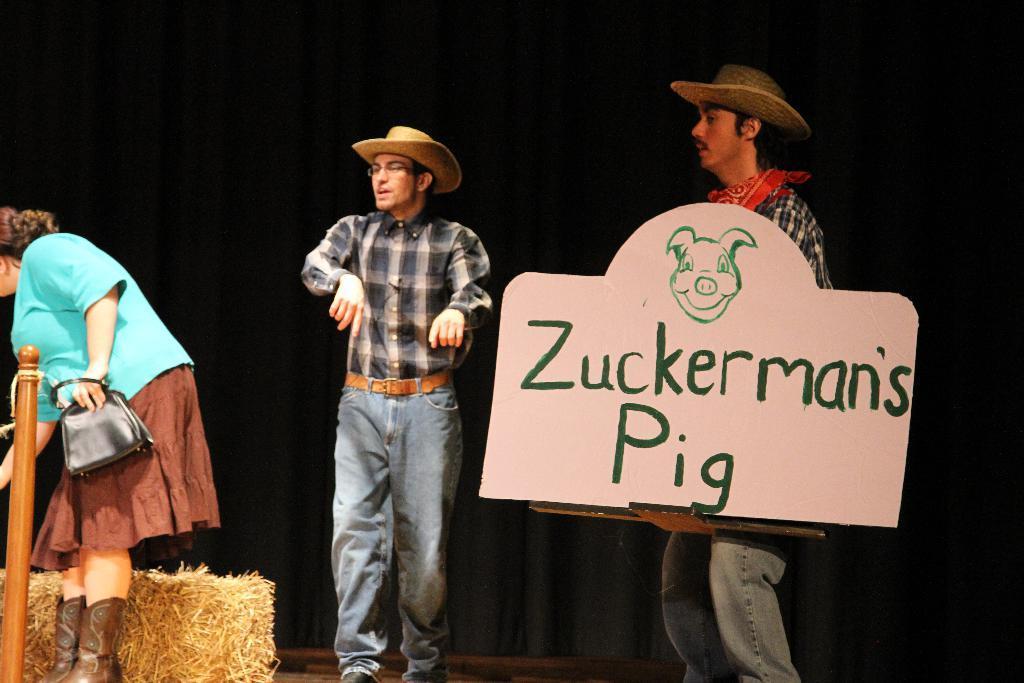Can you describe this image briefly? In this image i can see 2 men and a woman. woman is holding a bag and a man on the right side is holding a board in his hand. In the background i can see a black curtain. 